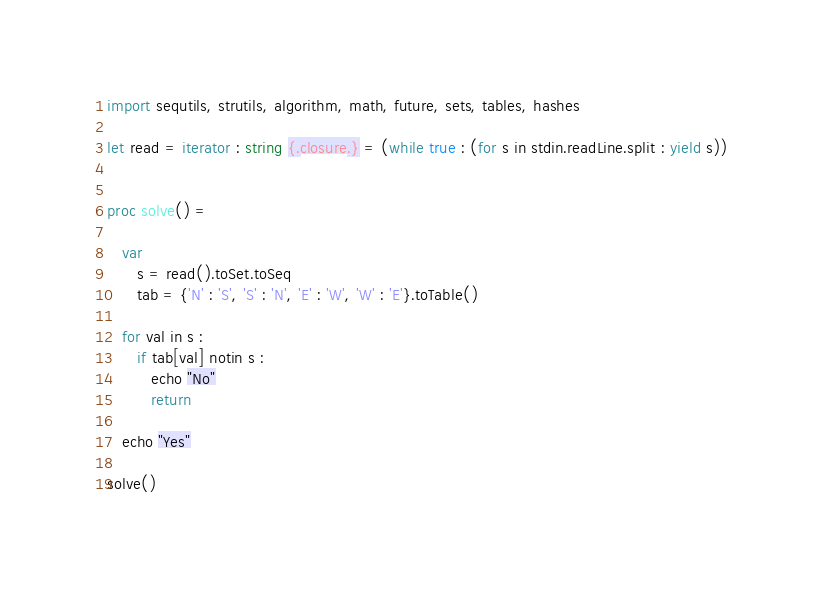Convert code to text. <code><loc_0><loc_0><loc_500><loc_500><_Nim_>import sequtils, strutils, algorithm, math, future, sets, tables, hashes

let read = iterator : string {.closure.} = (while true : (for s in stdin.readLine.split : yield s))


proc solve() =
   
   var
      s = read().toSet.toSeq
      tab = {'N' : 'S', 'S' : 'N', 'E' : 'W', 'W' : 'E'}.toTable()

   for val in s : 
      if tab[val] notin s : 
         echo "No"
         return

   echo "Yes"

solve()</code> 